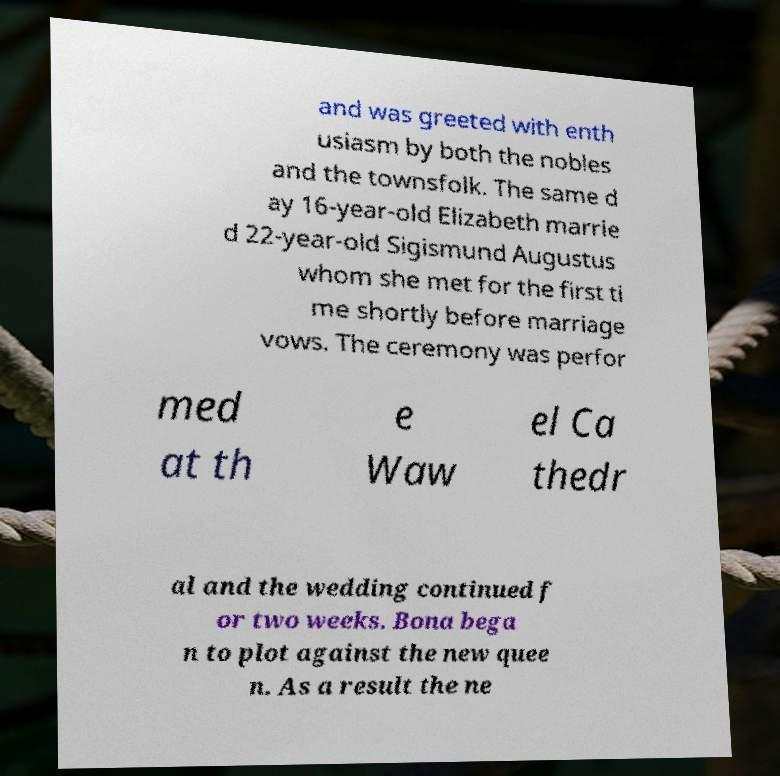Please read and relay the text visible in this image. What does it say? and was greeted with enth usiasm by both the nobles and the townsfolk. The same d ay 16-year-old Elizabeth marrie d 22-year-old Sigismund Augustus whom she met for the first ti me shortly before marriage vows. The ceremony was perfor med at th e Waw el Ca thedr al and the wedding continued f or two weeks. Bona bega n to plot against the new quee n. As a result the ne 